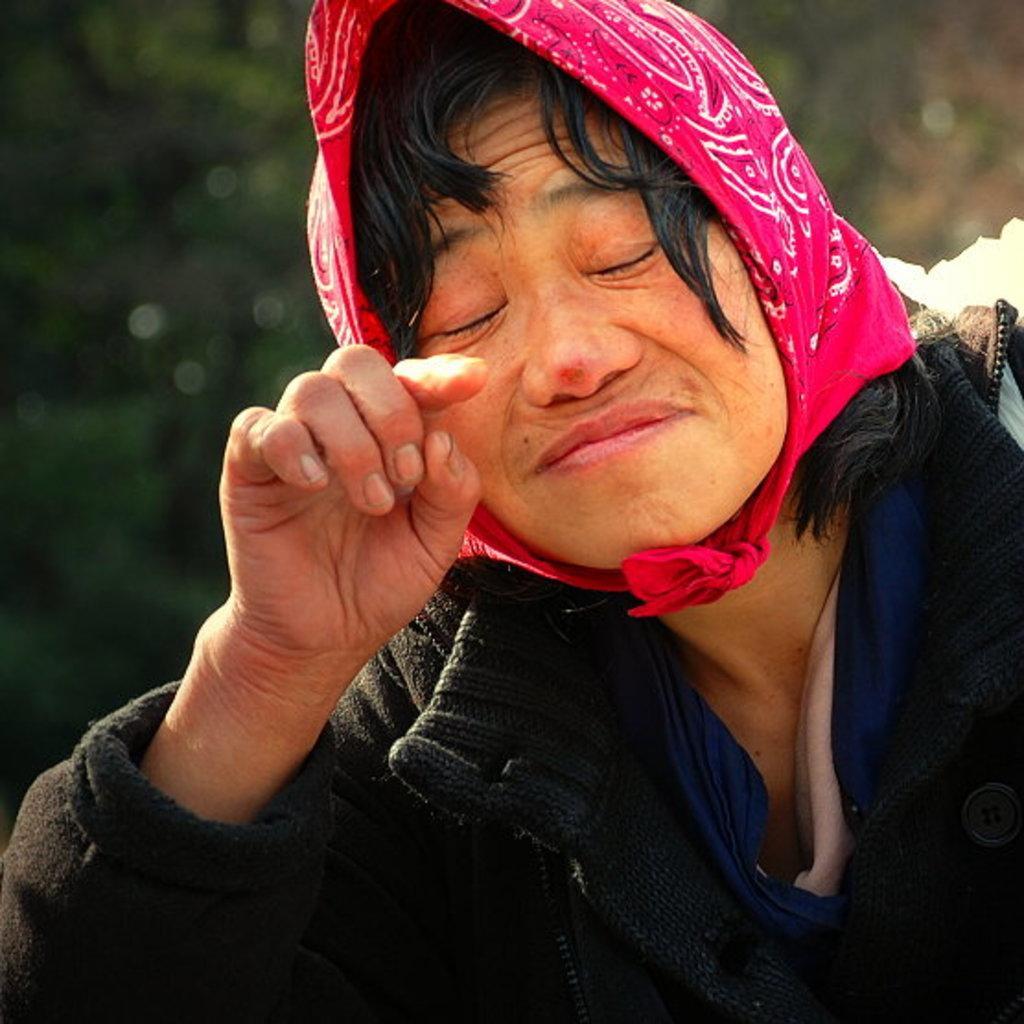Describe this image in one or two sentences. As we can see in the image in the front there is a person wearing black color jacket and in the background there are trees. The background is blurred. 